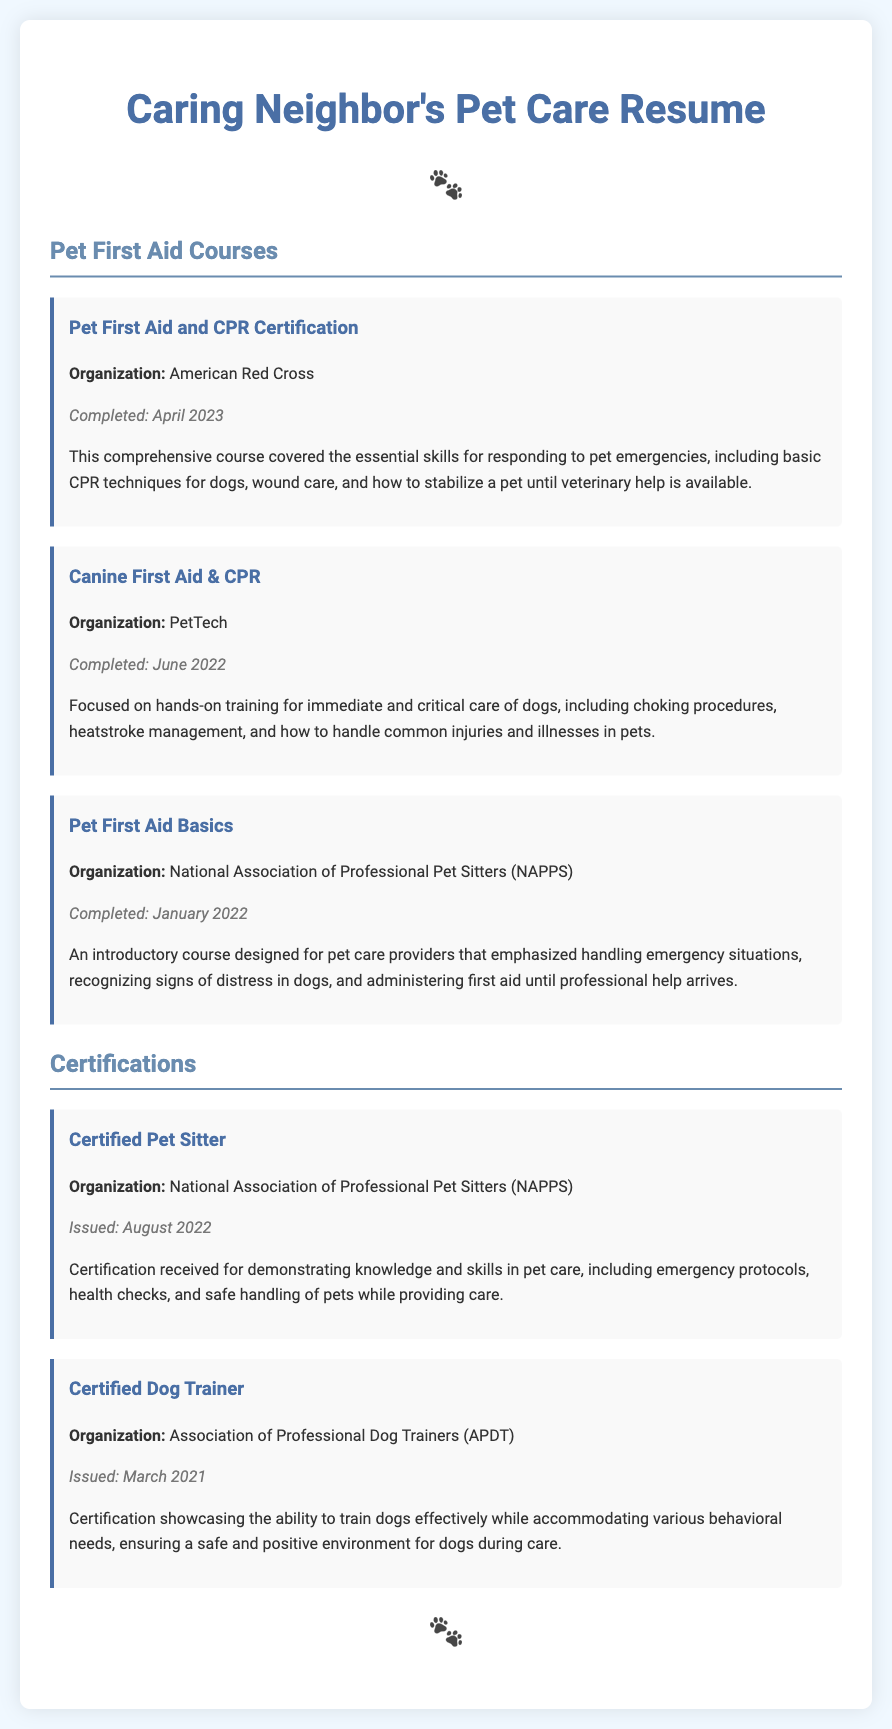What is the name of the first aid certification? The document states the first aid certification is titled "Pet First Aid and CPR Certification."
Answer: Pet First Aid and CPR Certification Who issued the "Certified Pet Sitter" credential? The certification for "Certified Pet Sitter" was issued by the National Association of Professional Pet Sitters (NAPPS).
Answer: National Association of Professional Pet Sitters When was the "Canine First Aid & CPR" course completed? The document notes that the "Canine First Aid & CPR" course was completed in June 2022.
Answer: June 2022 What essential skill is covered in the Pet First Aid and CPR Certification? The course covers various skills, including basic CPR techniques for dogs.
Answer: Basic CPR techniques How many pet first aid courses are listed in the document? The document lists a total of three pet first aid courses.
Answer: Three Which organization provided the "Pet First Aid Basics" course? The organization that provided the "Pet First Aid Basics" course is the National Association of Professional Pet Sitters (NAPPS).
Answer: National Association of Professional Pet Sitters What is the focus of the "Canine First Aid & CPR" course? The focus is on hands-on training for immediate and critical care of dogs.
Answer: Immediate and critical care of dogs What type of document is presented here? This document type is a resume, specifically for pet care.
Answer: Resume 